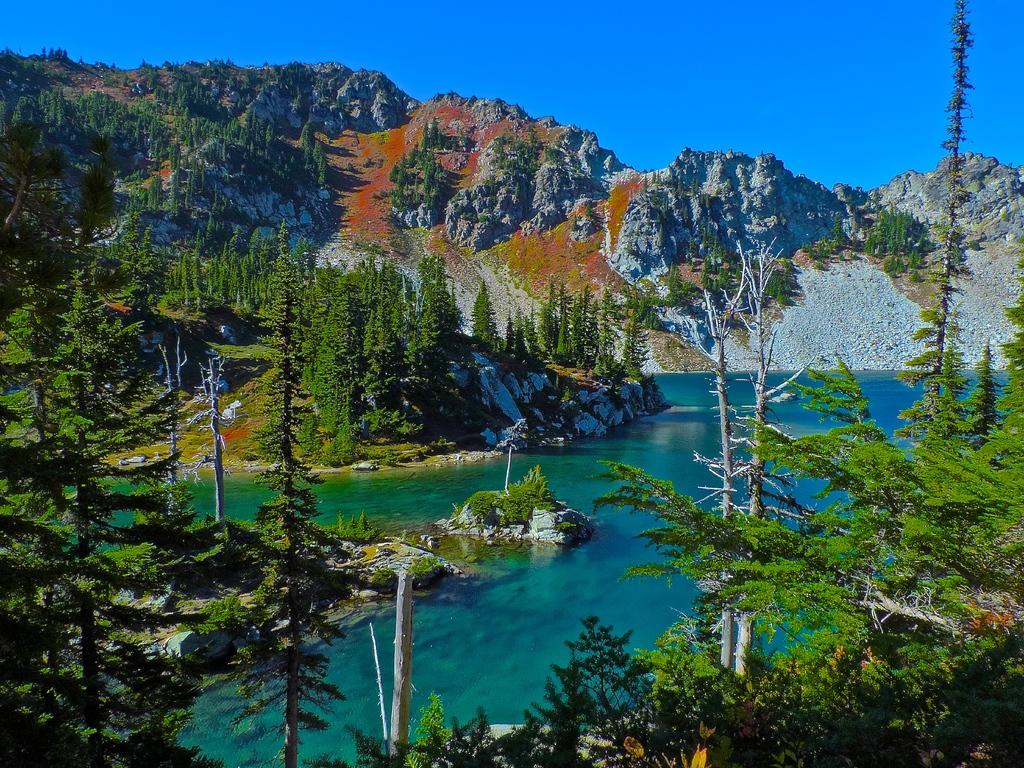What type of vegetation can be seen in the image? There are trees in the image. What natural feature is visible in the image? There is water visible in the image. What geographical feature can be seen in the distance? There are mountains in the image. What type of ground cover is present in the image? There is grass in the image. What part of the natural environment is visible in the image? The sky is visible in the image. How many roses are present in the image? There are no roses visible in the image. What type of memory can be seen in the image? There is no memory present in the image; it is a photograph of natural elements. 